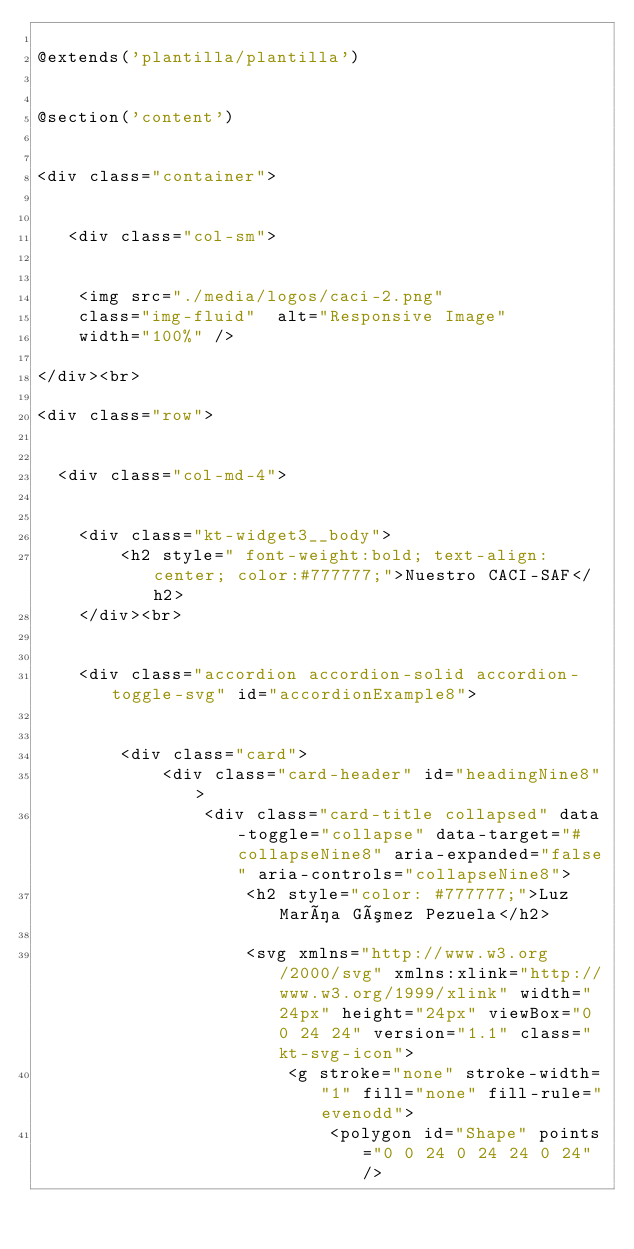Convert code to text. <code><loc_0><loc_0><loc_500><loc_500><_PHP_>
@extends('plantilla/plantilla')


@section('content')


<div class="container">


   <div class="col-sm">


    <img src="./media/logos/caci-2.png" 
    class="img-fluid"  alt="Responsive Image" 
    width="100%" /> 

</div><br>

<div class="row">


  <div class="col-md-4">


    <div class="kt-widget3__body">
        <h2 style=" font-weight:bold; text-align: center; color:#777777;">Nuestro CACI-SAF</h2>
    </div><br>


    <div class="accordion accordion-solid accordion-toggle-svg" id="accordionExample8">


        <div class="card">
            <div class="card-header" id="headingNine8">
                <div class="card-title collapsed" data-toggle="collapse" data-target="#collapseNine8" aria-expanded="false" aria-controls="collapseNine8">
                    <h2 style="color: #777777;">Luz María Gómez Pezuela</h2>

                    <svg xmlns="http://www.w3.org/2000/svg" xmlns:xlink="http://www.w3.org/1999/xlink" width="24px" height="24px" viewBox="0 0 24 24" version="1.1" class="kt-svg-icon">
                        <g stroke="none" stroke-width="1" fill="none" fill-rule="evenodd">
                            <polygon id="Shape" points="0 0 24 0 24 24 0 24"/></code> 